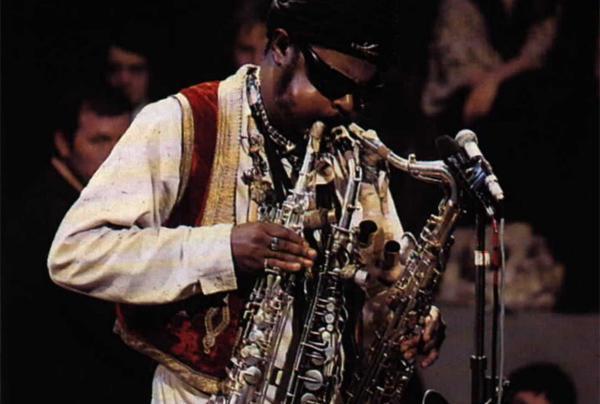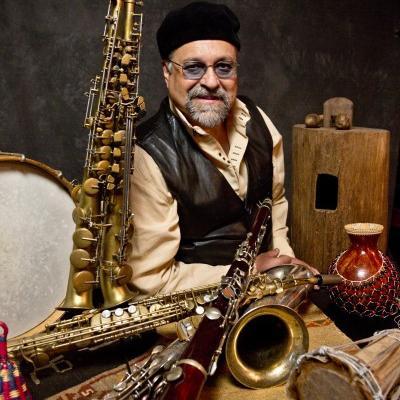The first image is the image on the left, the second image is the image on the right. Given the left and right images, does the statement "Each image shows a man with an oversized gold saxophone, and in at least one image, the saxophone is on a black stand." hold true? Answer yes or no. No. The first image is the image on the left, the second image is the image on the right. Assess this claim about the two images: "In at least one  image there is a young man with a supersized saxophone tilted right and strapped to him while he is playing it.". Correct or not? Answer yes or no. No. 